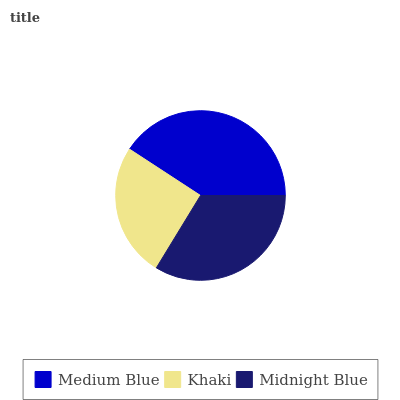Is Khaki the minimum?
Answer yes or no. Yes. Is Medium Blue the maximum?
Answer yes or no. Yes. Is Midnight Blue the minimum?
Answer yes or no. No. Is Midnight Blue the maximum?
Answer yes or no. No. Is Midnight Blue greater than Khaki?
Answer yes or no. Yes. Is Khaki less than Midnight Blue?
Answer yes or no. Yes. Is Khaki greater than Midnight Blue?
Answer yes or no. No. Is Midnight Blue less than Khaki?
Answer yes or no. No. Is Midnight Blue the high median?
Answer yes or no. Yes. Is Midnight Blue the low median?
Answer yes or no. Yes. Is Khaki the high median?
Answer yes or no. No. Is Khaki the low median?
Answer yes or no. No. 